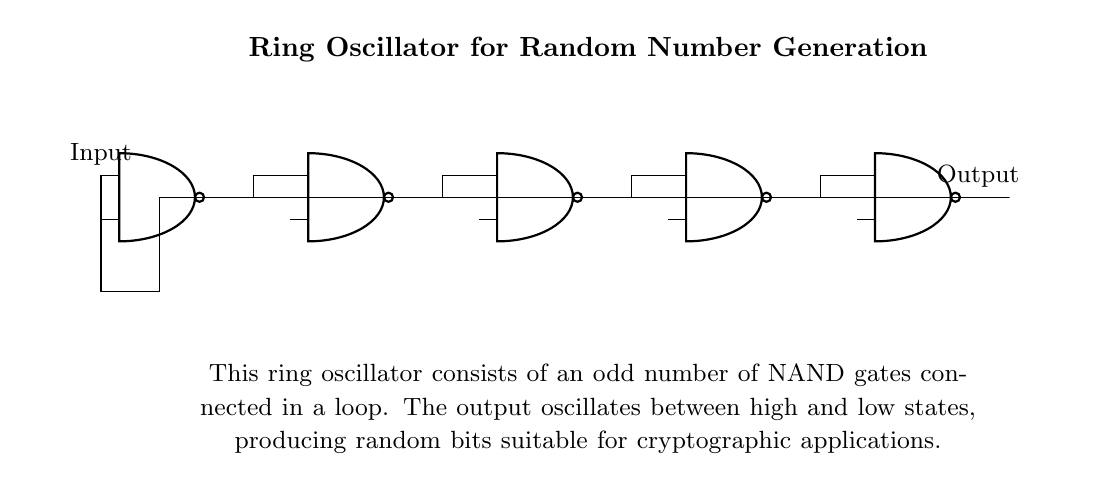What type of gates are used in this circuit? The circuit uses NAND gates, which are identified by the specific symbols shown for each gate in the diagram.
Answer: NAND gates How many NAND gates are connected in the ring oscillator? There are five NAND gates connected in a loop, which is seen from the sequential arrangement of the gates in the circuit diagram.
Answer: Five What is the primary function of this ring oscillator? The primary function is to generate random bits, which is indicated in the diagram's explanatory section regarding its use in cryptographic applications.
Answer: Generate random bits How do the outputs of the NAND gates contribute to the oscillation? Each NAND gate feeds into the next, creating a feedback loop that causes the output to oscillate between high and low states, as described in the explanation beneath the circuit diagram.
Answer: Feedback loop What type of application is this ring oscillator suited for? The oscillator is specifically suited for cryptographic applications, which is directly mentioned in the diagram’s explanatory text.
Answer: Cryptographic applications Why does the circuit use an odd number of NAND gates? An odd number of gates ensures that the feedback circuit does not stabilize at a constant state, allowing for continuous oscillation and thus randomness, which is necessary for its function in generating random numbers.
Answer: Continuous oscillation What is the nature of the output of this ring oscillator? The output oscillates between high and low states, as reflected in the description that highlights the function of producing random bits.
Answer: Oscillates between high and low states 